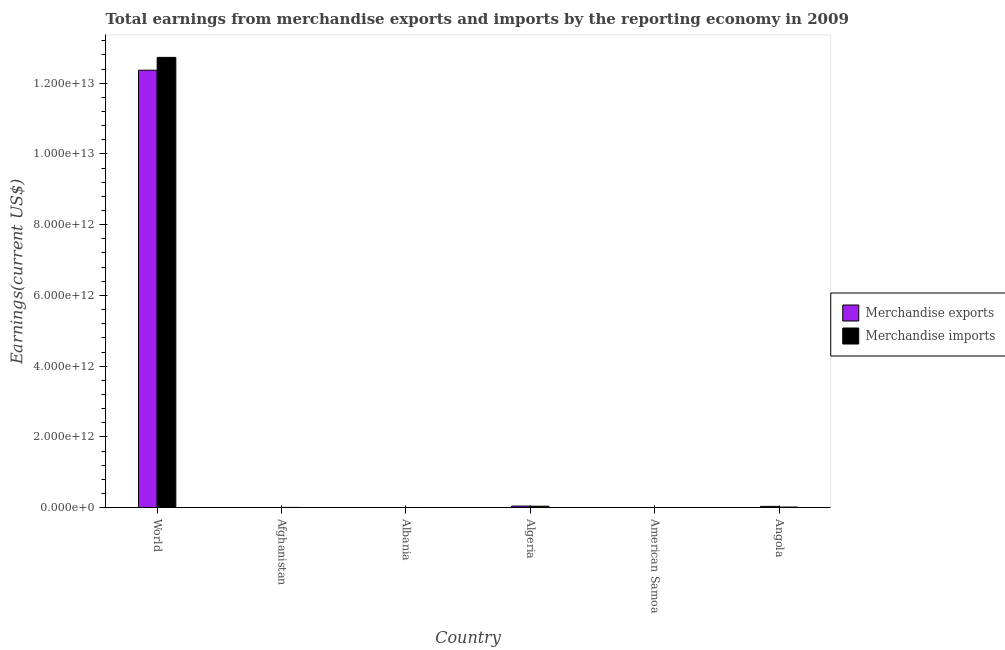Are the number of bars per tick equal to the number of legend labels?
Keep it short and to the point. Yes. Are the number of bars on each tick of the X-axis equal?
Provide a succinct answer. Yes. How many bars are there on the 3rd tick from the left?
Keep it short and to the point. 2. What is the label of the 2nd group of bars from the left?
Offer a very short reply. Afghanistan. What is the earnings from merchandise imports in Afghanistan?
Ensure brevity in your answer.  6.95e+09. Across all countries, what is the maximum earnings from merchandise imports?
Provide a short and direct response. 1.27e+13. Across all countries, what is the minimum earnings from merchandise imports?
Provide a short and direct response. 1.61e+08. In which country was the earnings from merchandise imports minimum?
Provide a short and direct response. American Samoa. What is the total earnings from merchandise exports in the graph?
Make the answer very short. 1.25e+13. What is the difference between the earnings from merchandise imports in Algeria and that in World?
Provide a short and direct response. -1.27e+13. What is the difference between the earnings from merchandise imports in Algeria and the earnings from merchandise exports in World?
Give a very brief answer. -1.23e+13. What is the average earnings from merchandise exports per country?
Your answer should be compact. 2.08e+12. What is the difference between the earnings from merchandise exports and earnings from merchandise imports in Angola?
Offer a very short reply. 1.85e+1. In how many countries, is the earnings from merchandise imports greater than 10400000000000 US$?
Offer a very short reply. 1. What is the ratio of the earnings from merchandise exports in Afghanistan to that in Angola?
Your response must be concise. 0.01. Is the difference between the earnings from merchandise exports in Albania and Angola greater than the difference between the earnings from merchandise imports in Albania and Angola?
Your response must be concise. No. What is the difference between the highest and the second highest earnings from merchandise exports?
Your answer should be very brief. 1.23e+13. What is the difference between the highest and the lowest earnings from merchandise imports?
Your response must be concise. 1.27e+13. Is the sum of the earnings from merchandise exports in American Samoa and Angola greater than the maximum earnings from merchandise imports across all countries?
Provide a succinct answer. No. What does the 2nd bar from the right in American Samoa represents?
Make the answer very short. Merchandise exports. How many bars are there?
Keep it short and to the point. 12. Are all the bars in the graph horizontal?
Your response must be concise. No. What is the difference between two consecutive major ticks on the Y-axis?
Provide a short and direct response. 2.00e+12. Are the values on the major ticks of Y-axis written in scientific E-notation?
Your answer should be very brief. Yes. Does the graph contain any zero values?
Your answer should be compact. No. Does the graph contain grids?
Offer a very short reply. No. Where does the legend appear in the graph?
Provide a short and direct response. Center right. How many legend labels are there?
Your answer should be very brief. 2. What is the title of the graph?
Provide a short and direct response. Total earnings from merchandise exports and imports by the reporting economy in 2009. What is the label or title of the Y-axis?
Your answer should be very brief. Earnings(current US$). What is the Earnings(current US$) of Merchandise exports in World?
Keep it short and to the point. 1.24e+13. What is the Earnings(current US$) in Merchandise imports in World?
Your response must be concise. 1.27e+13. What is the Earnings(current US$) of Merchandise exports in Afghanistan?
Your response must be concise. 4.46e+08. What is the Earnings(current US$) in Merchandise imports in Afghanistan?
Make the answer very short. 6.95e+09. What is the Earnings(current US$) of Merchandise exports in Albania?
Provide a succinct answer. 1.10e+09. What is the Earnings(current US$) of Merchandise imports in Albania?
Ensure brevity in your answer.  4.44e+09. What is the Earnings(current US$) in Merchandise exports in Algeria?
Provide a short and direct response. 4.52e+1. What is the Earnings(current US$) of Merchandise imports in Algeria?
Provide a short and direct response. 4.07e+1. What is the Earnings(current US$) of Merchandise exports in American Samoa?
Offer a terse response. 1.98e+07. What is the Earnings(current US$) of Merchandise imports in American Samoa?
Provide a short and direct response. 1.61e+08. What is the Earnings(current US$) in Merchandise exports in Angola?
Ensure brevity in your answer.  3.60e+1. What is the Earnings(current US$) of Merchandise imports in Angola?
Ensure brevity in your answer.  1.75e+1. Across all countries, what is the maximum Earnings(current US$) in Merchandise exports?
Keep it short and to the point. 1.24e+13. Across all countries, what is the maximum Earnings(current US$) in Merchandise imports?
Ensure brevity in your answer.  1.27e+13. Across all countries, what is the minimum Earnings(current US$) of Merchandise exports?
Offer a terse response. 1.98e+07. Across all countries, what is the minimum Earnings(current US$) of Merchandise imports?
Make the answer very short. 1.61e+08. What is the total Earnings(current US$) in Merchandise exports in the graph?
Provide a short and direct response. 1.25e+13. What is the total Earnings(current US$) in Merchandise imports in the graph?
Your response must be concise. 1.28e+13. What is the difference between the Earnings(current US$) in Merchandise exports in World and that in Afghanistan?
Offer a very short reply. 1.24e+13. What is the difference between the Earnings(current US$) in Merchandise imports in World and that in Afghanistan?
Give a very brief answer. 1.27e+13. What is the difference between the Earnings(current US$) of Merchandise exports in World and that in Albania?
Provide a short and direct response. 1.24e+13. What is the difference between the Earnings(current US$) of Merchandise imports in World and that in Albania?
Offer a very short reply. 1.27e+13. What is the difference between the Earnings(current US$) of Merchandise exports in World and that in Algeria?
Provide a short and direct response. 1.23e+13. What is the difference between the Earnings(current US$) in Merchandise imports in World and that in Algeria?
Provide a succinct answer. 1.27e+13. What is the difference between the Earnings(current US$) of Merchandise exports in World and that in American Samoa?
Offer a terse response. 1.24e+13. What is the difference between the Earnings(current US$) in Merchandise imports in World and that in American Samoa?
Your response must be concise. 1.27e+13. What is the difference between the Earnings(current US$) of Merchandise exports in World and that in Angola?
Make the answer very short. 1.23e+13. What is the difference between the Earnings(current US$) in Merchandise imports in World and that in Angola?
Ensure brevity in your answer.  1.27e+13. What is the difference between the Earnings(current US$) of Merchandise exports in Afghanistan and that in Albania?
Your answer should be compact. -6.55e+08. What is the difference between the Earnings(current US$) in Merchandise imports in Afghanistan and that in Albania?
Keep it short and to the point. 2.51e+09. What is the difference between the Earnings(current US$) in Merchandise exports in Afghanistan and that in Algeria?
Provide a short and direct response. -4.47e+1. What is the difference between the Earnings(current US$) of Merchandise imports in Afghanistan and that in Algeria?
Ensure brevity in your answer.  -3.38e+1. What is the difference between the Earnings(current US$) in Merchandise exports in Afghanistan and that in American Samoa?
Provide a short and direct response. 4.26e+08. What is the difference between the Earnings(current US$) in Merchandise imports in Afghanistan and that in American Samoa?
Provide a short and direct response. 6.79e+09. What is the difference between the Earnings(current US$) of Merchandise exports in Afghanistan and that in Angola?
Make the answer very short. -3.56e+1. What is the difference between the Earnings(current US$) in Merchandise imports in Afghanistan and that in Angola?
Keep it short and to the point. -1.05e+1. What is the difference between the Earnings(current US$) in Merchandise exports in Albania and that in Algeria?
Your answer should be very brief. -4.41e+1. What is the difference between the Earnings(current US$) of Merchandise imports in Albania and that in Algeria?
Offer a terse response. -3.63e+1. What is the difference between the Earnings(current US$) of Merchandise exports in Albania and that in American Samoa?
Offer a very short reply. 1.08e+09. What is the difference between the Earnings(current US$) of Merchandise imports in Albania and that in American Samoa?
Offer a terse response. 4.28e+09. What is the difference between the Earnings(current US$) of Merchandise exports in Albania and that in Angola?
Provide a succinct answer. -3.49e+1. What is the difference between the Earnings(current US$) of Merchandise imports in Albania and that in Angola?
Offer a very short reply. -1.30e+1. What is the difference between the Earnings(current US$) of Merchandise exports in Algeria and that in American Samoa?
Offer a very short reply. 4.52e+1. What is the difference between the Earnings(current US$) in Merchandise imports in Algeria and that in American Samoa?
Your answer should be very brief. 4.06e+1. What is the difference between the Earnings(current US$) in Merchandise exports in Algeria and that in Angola?
Provide a succinct answer. 9.19e+09. What is the difference between the Earnings(current US$) in Merchandise imports in Algeria and that in Angola?
Keep it short and to the point. 2.32e+1. What is the difference between the Earnings(current US$) of Merchandise exports in American Samoa and that in Angola?
Ensure brevity in your answer.  -3.60e+1. What is the difference between the Earnings(current US$) of Merchandise imports in American Samoa and that in Angola?
Keep it short and to the point. -1.73e+1. What is the difference between the Earnings(current US$) of Merchandise exports in World and the Earnings(current US$) of Merchandise imports in Afghanistan?
Offer a terse response. 1.24e+13. What is the difference between the Earnings(current US$) in Merchandise exports in World and the Earnings(current US$) in Merchandise imports in Albania?
Provide a short and direct response. 1.24e+13. What is the difference between the Earnings(current US$) of Merchandise exports in World and the Earnings(current US$) of Merchandise imports in Algeria?
Your response must be concise. 1.23e+13. What is the difference between the Earnings(current US$) of Merchandise exports in World and the Earnings(current US$) of Merchandise imports in American Samoa?
Keep it short and to the point. 1.24e+13. What is the difference between the Earnings(current US$) of Merchandise exports in World and the Earnings(current US$) of Merchandise imports in Angola?
Keep it short and to the point. 1.24e+13. What is the difference between the Earnings(current US$) in Merchandise exports in Afghanistan and the Earnings(current US$) in Merchandise imports in Albania?
Make the answer very short. -3.99e+09. What is the difference between the Earnings(current US$) in Merchandise exports in Afghanistan and the Earnings(current US$) in Merchandise imports in Algeria?
Provide a succinct answer. -4.03e+1. What is the difference between the Earnings(current US$) of Merchandise exports in Afghanistan and the Earnings(current US$) of Merchandise imports in American Samoa?
Offer a terse response. 2.85e+08. What is the difference between the Earnings(current US$) of Merchandise exports in Afghanistan and the Earnings(current US$) of Merchandise imports in Angola?
Your response must be concise. -1.70e+1. What is the difference between the Earnings(current US$) of Merchandise exports in Albania and the Earnings(current US$) of Merchandise imports in Algeria?
Keep it short and to the point. -3.96e+1. What is the difference between the Earnings(current US$) of Merchandise exports in Albania and the Earnings(current US$) of Merchandise imports in American Samoa?
Offer a terse response. 9.40e+08. What is the difference between the Earnings(current US$) of Merchandise exports in Albania and the Earnings(current US$) of Merchandise imports in Angola?
Provide a succinct answer. -1.64e+1. What is the difference between the Earnings(current US$) of Merchandise exports in Algeria and the Earnings(current US$) of Merchandise imports in American Samoa?
Keep it short and to the point. 4.50e+1. What is the difference between the Earnings(current US$) in Merchandise exports in Algeria and the Earnings(current US$) in Merchandise imports in Angola?
Give a very brief answer. 2.77e+1. What is the difference between the Earnings(current US$) in Merchandise exports in American Samoa and the Earnings(current US$) in Merchandise imports in Angola?
Provide a succinct answer. -1.75e+1. What is the average Earnings(current US$) in Merchandise exports per country?
Your answer should be very brief. 2.08e+12. What is the average Earnings(current US$) in Merchandise imports per country?
Offer a terse response. 2.13e+12. What is the difference between the Earnings(current US$) in Merchandise exports and Earnings(current US$) in Merchandise imports in World?
Your answer should be compact. -3.62e+11. What is the difference between the Earnings(current US$) of Merchandise exports and Earnings(current US$) of Merchandise imports in Afghanistan?
Offer a terse response. -6.50e+09. What is the difference between the Earnings(current US$) of Merchandise exports and Earnings(current US$) of Merchandise imports in Albania?
Your answer should be compact. -3.34e+09. What is the difference between the Earnings(current US$) in Merchandise exports and Earnings(current US$) in Merchandise imports in Algeria?
Your answer should be compact. 4.46e+09. What is the difference between the Earnings(current US$) of Merchandise exports and Earnings(current US$) of Merchandise imports in American Samoa?
Provide a succinct answer. -1.41e+08. What is the difference between the Earnings(current US$) in Merchandise exports and Earnings(current US$) in Merchandise imports in Angola?
Offer a terse response. 1.85e+1. What is the ratio of the Earnings(current US$) in Merchandise exports in World to that in Afghanistan?
Your answer should be very brief. 2.77e+04. What is the ratio of the Earnings(current US$) in Merchandise imports in World to that in Afghanistan?
Your answer should be compact. 1832.19. What is the ratio of the Earnings(current US$) of Merchandise exports in World to that in Albania?
Offer a very short reply. 1.12e+04. What is the ratio of the Earnings(current US$) in Merchandise imports in World to that in Albania?
Make the answer very short. 2866.92. What is the ratio of the Earnings(current US$) in Merchandise exports in World to that in Algeria?
Keep it short and to the point. 273.69. What is the ratio of the Earnings(current US$) of Merchandise imports in World to that in Algeria?
Your answer should be compact. 312.59. What is the ratio of the Earnings(current US$) in Merchandise exports in World to that in American Samoa?
Provide a short and direct response. 6.23e+05. What is the ratio of the Earnings(current US$) of Merchandise imports in World to that in American Samoa?
Offer a terse response. 7.92e+04. What is the ratio of the Earnings(current US$) of Merchandise exports in World to that in Angola?
Your answer should be very brief. 343.55. What is the ratio of the Earnings(current US$) in Merchandise imports in World to that in Angola?
Provide a short and direct response. 728.24. What is the ratio of the Earnings(current US$) of Merchandise exports in Afghanistan to that in Albania?
Provide a short and direct response. 0.41. What is the ratio of the Earnings(current US$) of Merchandise imports in Afghanistan to that in Albania?
Your answer should be compact. 1.56. What is the ratio of the Earnings(current US$) in Merchandise exports in Afghanistan to that in Algeria?
Provide a succinct answer. 0.01. What is the ratio of the Earnings(current US$) of Merchandise imports in Afghanistan to that in Algeria?
Your answer should be compact. 0.17. What is the ratio of the Earnings(current US$) of Merchandise exports in Afghanistan to that in American Samoa?
Make the answer very short. 22.47. What is the ratio of the Earnings(current US$) in Merchandise imports in Afghanistan to that in American Samoa?
Provide a succinct answer. 43.24. What is the ratio of the Earnings(current US$) in Merchandise exports in Afghanistan to that in Angola?
Provide a short and direct response. 0.01. What is the ratio of the Earnings(current US$) in Merchandise imports in Afghanistan to that in Angola?
Your answer should be very brief. 0.4. What is the ratio of the Earnings(current US$) of Merchandise exports in Albania to that in Algeria?
Give a very brief answer. 0.02. What is the ratio of the Earnings(current US$) of Merchandise imports in Albania to that in Algeria?
Give a very brief answer. 0.11. What is the ratio of the Earnings(current US$) of Merchandise exports in Albania to that in American Samoa?
Give a very brief answer. 55.45. What is the ratio of the Earnings(current US$) in Merchandise imports in Albania to that in American Samoa?
Provide a succinct answer. 27.63. What is the ratio of the Earnings(current US$) in Merchandise exports in Albania to that in Angola?
Provide a succinct answer. 0.03. What is the ratio of the Earnings(current US$) in Merchandise imports in Albania to that in Angola?
Your response must be concise. 0.25. What is the ratio of the Earnings(current US$) in Merchandise exports in Algeria to that in American Samoa?
Give a very brief answer. 2277.14. What is the ratio of the Earnings(current US$) in Merchandise imports in Algeria to that in American Samoa?
Provide a short and direct response. 253.42. What is the ratio of the Earnings(current US$) in Merchandise exports in Algeria to that in Angola?
Keep it short and to the point. 1.26. What is the ratio of the Earnings(current US$) of Merchandise imports in Algeria to that in Angola?
Provide a short and direct response. 2.33. What is the ratio of the Earnings(current US$) in Merchandise exports in American Samoa to that in Angola?
Your response must be concise. 0. What is the ratio of the Earnings(current US$) of Merchandise imports in American Samoa to that in Angola?
Ensure brevity in your answer.  0.01. What is the difference between the highest and the second highest Earnings(current US$) of Merchandise exports?
Provide a succinct answer. 1.23e+13. What is the difference between the highest and the second highest Earnings(current US$) in Merchandise imports?
Ensure brevity in your answer.  1.27e+13. What is the difference between the highest and the lowest Earnings(current US$) of Merchandise exports?
Your response must be concise. 1.24e+13. What is the difference between the highest and the lowest Earnings(current US$) in Merchandise imports?
Your answer should be very brief. 1.27e+13. 